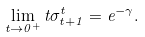Convert formula to latex. <formula><loc_0><loc_0><loc_500><loc_500>\lim _ { t \rightarrow 0 ^ { + } } t \sigma _ { t + 1 } ^ { t } = e ^ { - \gamma } .</formula> 